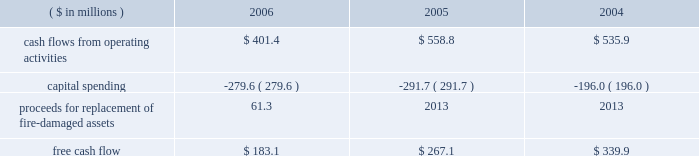Page 29 of 98 in connection with the internal revenue service 2019s ( irs ) examination of ball 2019s consolidated income tax returns for the tax years 2000 through 2004 , the irs has proposed to disallow ball 2019s deductions of interest expense incurred on loans under a company-owned life insurance plan that has been in place for more than 20 years .
Ball believes that its interest deductions will be sustained as filed and , therefore , no provision for loss has been recorded .
The total potential liability for the audit years 1999 through 2004 , unaudited year 2005 and an estimate of the impact on 2006 is approximately $ 31 million , excluding related interest .
The irs has withdrawn its proposed adjustments for any penalties .
See note 13 accompanying the consolidated financial statements within item 8 of this annual report .
Results of equity affiliates equity in the earnings of affiliates in 2006 is primarily attributable to our 50 percent ownership in packaging investments in the u.s .
And brazil .
Earnings in 2004 included the results of a minority-owned aerospace business , which was sold in october 2005 , and a $ 15.2 million loss representing ball 2019s share of a provision for doubtful accounts relating to its 35 percent interest in sanshui jfp ( discussed above in 201cmetal beverage packaging , europe/asia 201d ) .
After consideration of the prc loss , earnings were $ 14.7 million in 2006 compared to $ 15.5 million in 2005 and $ 15.8 million in 2004 .
Critical and significant accounting policies and new accounting pronouncements for information regarding the company 2019s critical and significant accounting policies , as well as recent accounting pronouncements , see note 1 to the consolidated financial statements within item 8 of this report .
Financial condition , liquidity and capital resources cash flows and capital expenditures cash flows from operating activities were $ 401.4 million in 2006 compared to $ 558.8 million in 2005 and $ 535.9 million in 2004 .
Management internally uses a free cash flow measure : ( 1 ) to evaluate the company 2019s operating results , ( 2 ) for planning purposes , ( 3 ) to evaluate strategic investments and ( 4 ) to evaluate the company 2019s ability to incur and service debt .
Free cash flow is not a defined term under u.s .
Generally accepted accounting principles , and it should not be inferred that the entire free cash flow amount is available for discretionary expenditures .
The company defines free cash flow as cash flow from operating activities less additions to property , plant and equipment ( capital spending ) .
Free cash flow is typically derived directly from the company 2019s cash flow statements ; however , it may be adjusted for items that affect comparability between periods .
An example of such an item included in 2006 is the property insurance proceeds for the replacement of the fire-damaged assets in our hassloch , germany , plant , which is included in capital spending amounts .
Based on this , our consolidated free cash flow is summarized as follows: .
Cash flows from operating activities in 2006 were negatively affected by higher cash pension funding and higher working capital levels compared to the prior year .
The higher working capital was a combination of higher than planned raw material inventory levels , higher income tax payments and higher accounts receivable balances , the latter resulting primarily from the repayment of a portion of the accounts receivable securitization program and late payments from customers in europe .
Management expects the increase in working capital to be temporary and that working capital levels will return to normal levels by the end of the first half of 2007. .
What was the difference in free cash flow between 2004 and 2005 in millions? 
Computations: (267.1 - 339.9)
Answer: -72.8. 